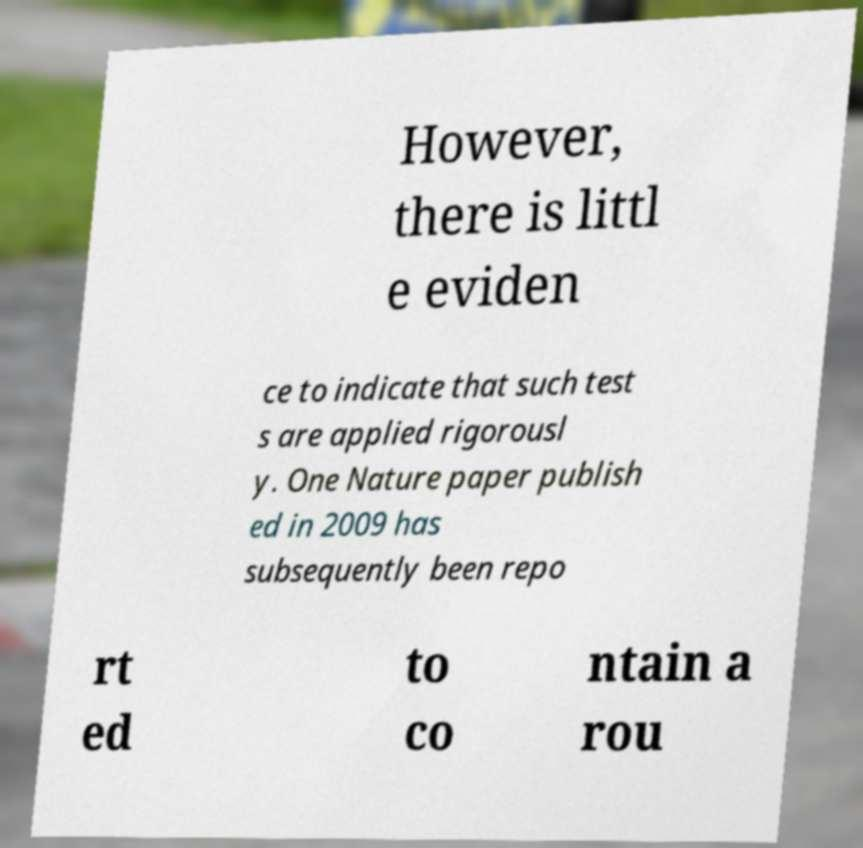Can you read and provide the text displayed in the image?This photo seems to have some interesting text. Can you extract and type it out for me? However, there is littl e eviden ce to indicate that such test s are applied rigorousl y. One Nature paper publish ed in 2009 has subsequently been repo rt ed to co ntain a rou 